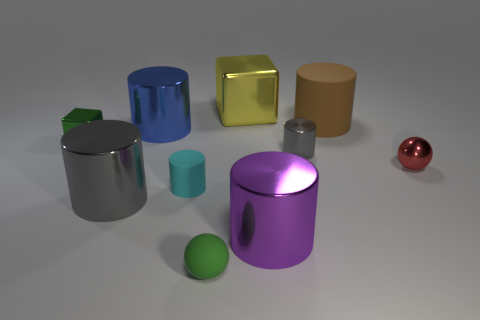There is a cyan thing; is it the same size as the gray object in front of the tiny gray metallic cylinder?
Your answer should be very brief. No. Is there a big matte sphere of the same color as the small block?
Your answer should be very brief. No. There is a green thing that is made of the same material as the cyan thing; what size is it?
Provide a succinct answer. Small. Is the material of the blue thing the same as the green block?
Your response must be concise. Yes. There is a matte cylinder that is on the right side of the tiny cylinder that is in front of the gray shiny cylinder that is behind the cyan rubber object; what is its color?
Provide a succinct answer. Brown. What shape is the big purple shiny thing?
Offer a very short reply. Cylinder. Do the large block and the cube that is in front of the large block have the same color?
Offer a very short reply. No. Are there an equal number of big yellow objects that are in front of the cyan object and gray rubber things?
Offer a very short reply. Yes. How many green shiny blocks have the same size as the green matte sphere?
Offer a very short reply. 1. There is a thing that is the same color as the tiny cube; what is its shape?
Your answer should be compact. Sphere. 